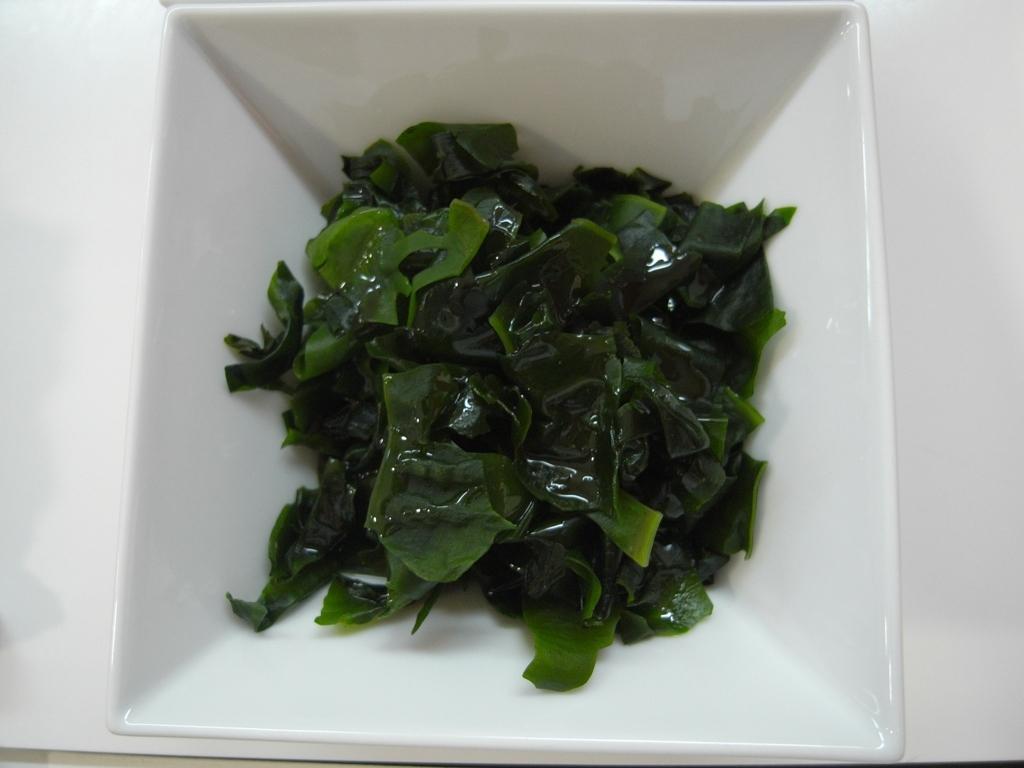Could you give a brief overview of what you see in this image? In this image I can see there is a bowl on the table. In the bowl there are some leafy vegetables. 